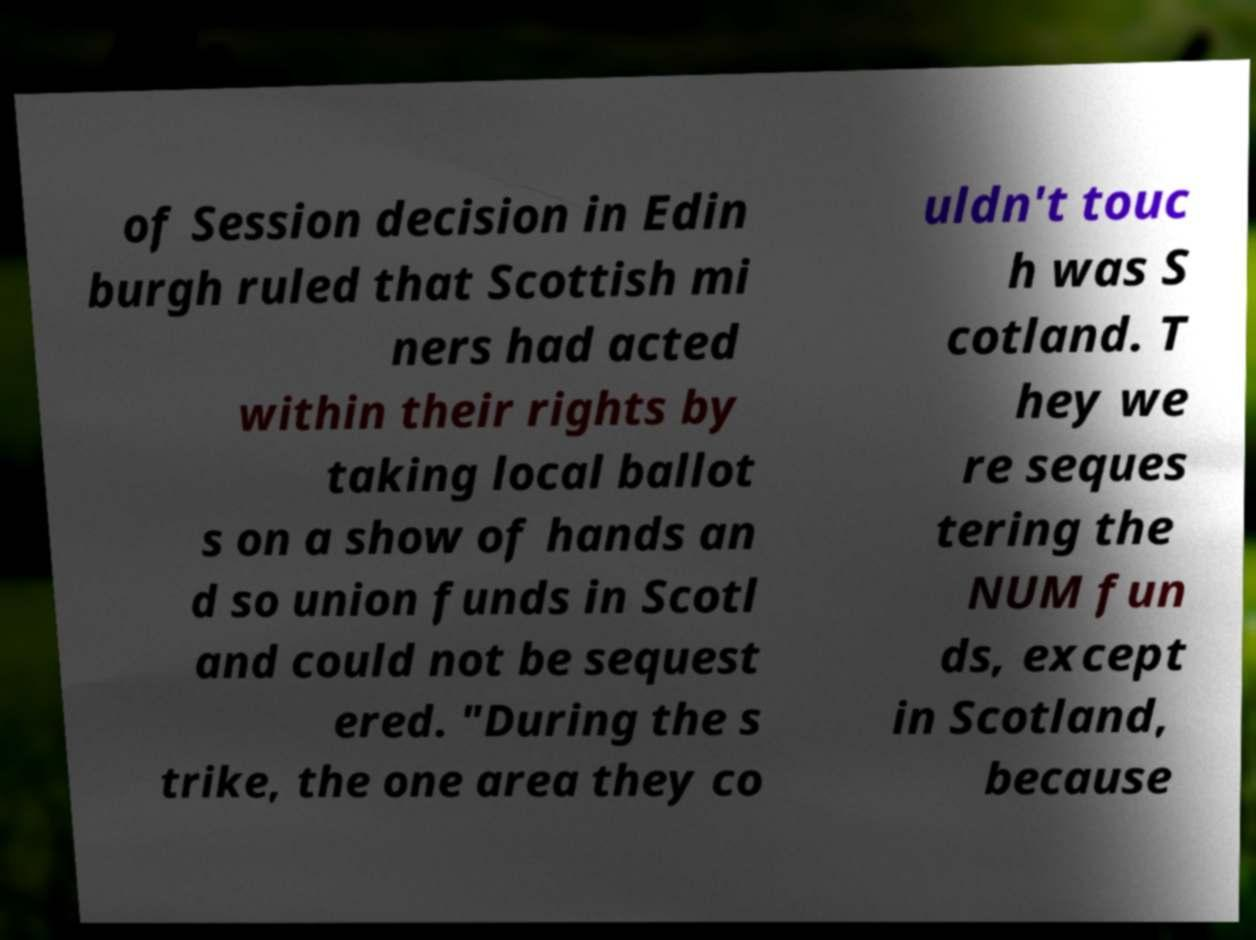Could you extract and type out the text from this image? of Session decision in Edin burgh ruled that Scottish mi ners had acted within their rights by taking local ballot s on a show of hands an d so union funds in Scotl and could not be sequest ered. "During the s trike, the one area they co uldn't touc h was S cotland. T hey we re seques tering the NUM fun ds, except in Scotland, because 